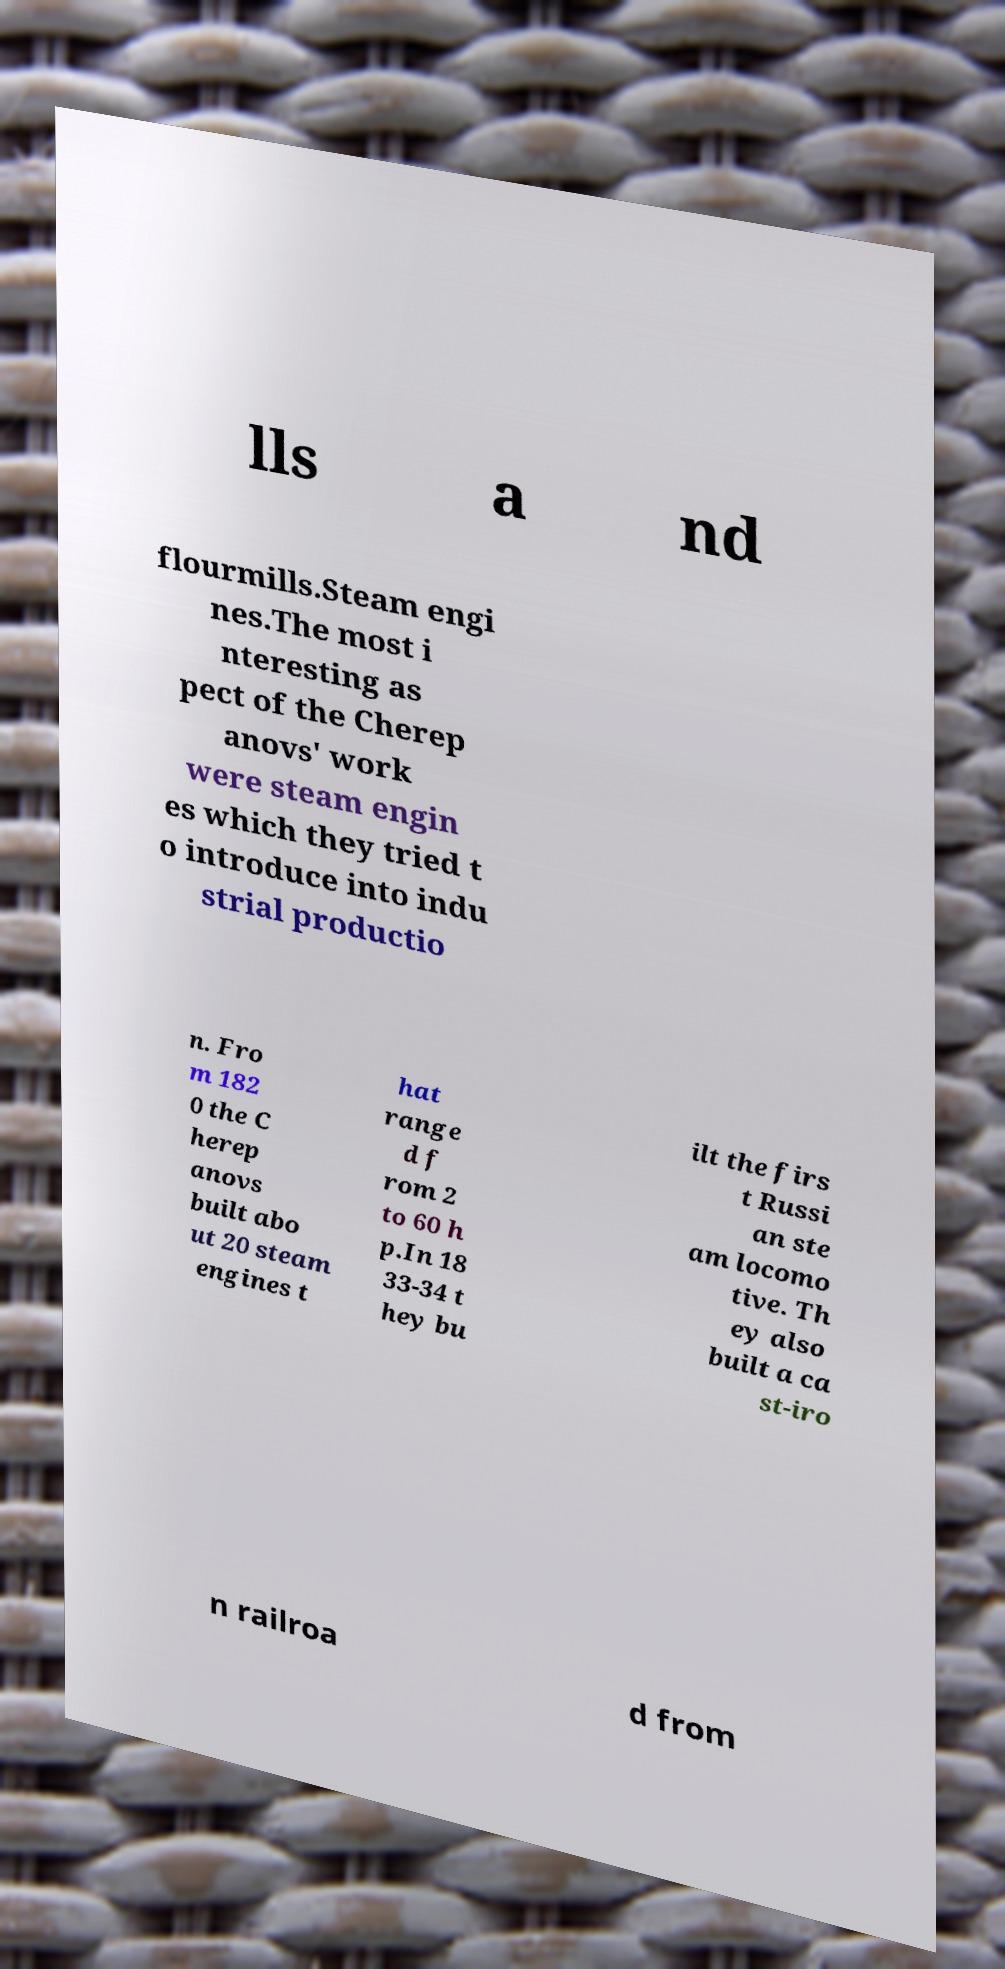Can you accurately transcribe the text from the provided image for me? lls a nd flourmills.Steam engi nes.The most i nteresting as pect of the Cherep anovs' work were steam engin es which they tried t o introduce into indu strial productio n. Fro m 182 0 the C herep anovs built abo ut 20 steam engines t hat range d f rom 2 to 60 h p.In 18 33-34 t hey bu ilt the firs t Russi an ste am locomo tive. Th ey also built a ca st-iro n railroa d from 